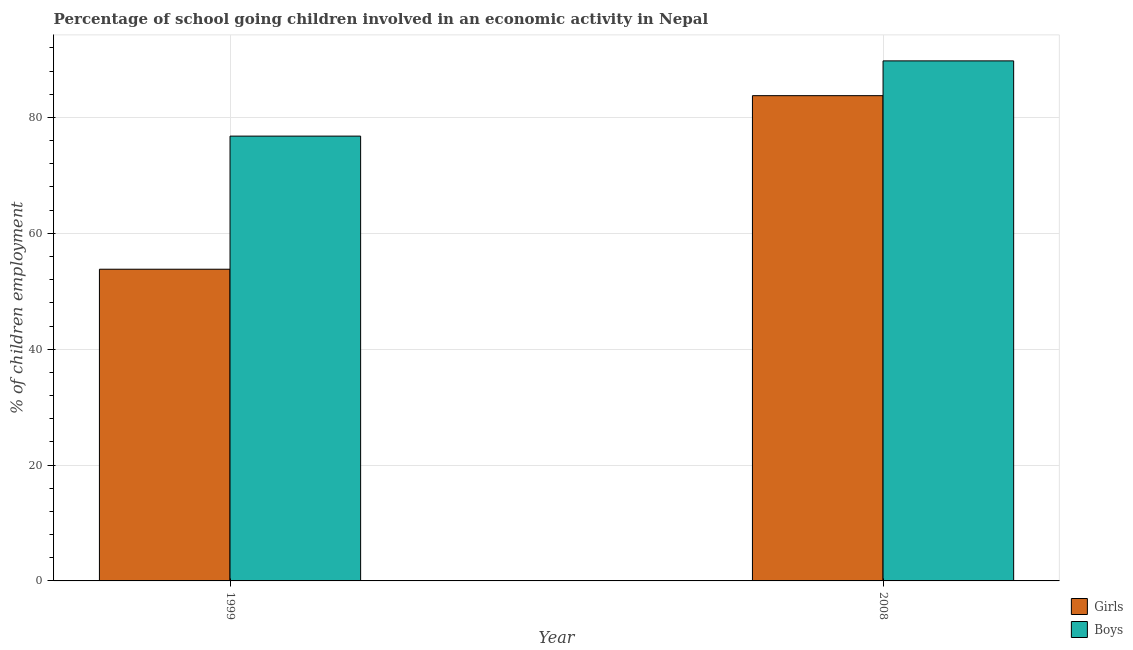How many different coloured bars are there?
Give a very brief answer. 2. Are the number of bars on each tick of the X-axis equal?
Make the answer very short. Yes. What is the label of the 2nd group of bars from the left?
Ensure brevity in your answer.  2008. What is the percentage of school going girls in 1999?
Ensure brevity in your answer.  53.8. Across all years, what is the maximum percentage of school going boys?
Offer a very short reply. 89.76. Across all years, what is the minimum percentage of school going girls?
Your answer should be compact. 53.8. In which year was the percentage of school going girls minimum?
Give a very brief answer. 1999. What is the total percentage of school going boys in the graph?
Provide a succinct answer. 166.54. What is the difference between the percentage of school going girls in 1999 and that in 2008?
Ensure brevity in your answer.  -29.96. What is the difference between the percentage of school going boys in 2008 and the percentage of school going girls in 1999?
Offer a very short reply. 12.99. What is the average percentage of school going girls per year?
Offer a very short reply. 68.78. In how many years, is the percentage of school going boys greater than 68 %?
Ensure brevity in your answer.  2. What is the ratio of the percentage of school going boys in 1999 to that in 2008?
Keep it short and to the point. 0.86. Is the percentage of school going boys in 1999 less than that in 2008?
Offer a very short reply. Yes. What does the 2nd bar from the left in 2008 represents?
Provide a short and direct response. Boys. What does the 1st bar from the right in 2008 represents?
Ensure brevity in your answer.  Boys. Are the values on the major ticks of Y-axis written in scientific E-notation?
Provide a short and direct response. No. Does the graph contain any zero values?
Offer a very short reply. No. How are the legend labels stacked?
Offer a very short reply. Vertical. What is the title of the graph?
Your response must be concise. Percentage of school going children involved in an economic activity in Nepal. What is the label or title of the X-axis?
Offer a terse response. Year. What is the label or title of the Y-axis?
Make the answer very short. % of children employment. What is the % of children employment of Girls in 1999?
Make the answer very short. 53.8. What is the % of children employment of Boys in 1999?
Ensure brevity in your answer.  76.78. What is the % of children employment in Girls in 2008?
Ensure brevity in your answer.  83.76. What is the % of children employment of Boys in 2008?
Keep it short and to the point. 89.76. Across all years, what is the maximum % of children employment in Girls?
Provide a short and direct response. 83.76. Across all years, what is the maximum % of children employment in Boys?
Give a very brief answer. 89.76. Across all years, what is the minimum % of children employment in Girls?
Make the answer very short. 53.8. Across all years, what is the minimum % of children employment in Boys?
Your response must be concise. 76.78. What is the total % of children employment in Girls in the graph?
Provide a succinct answer. 137.56. What is the total % of children employment of Boys in the graph?
Your answer should be compact. 166.54. What is the difference between the % of children employment of Girls in 1999 and that in 2008?
Provide a succinct answer. -29.96. What is the difference between the % of children employment of Boys in 1999 and that in 2008?
Keep it short and to the point. -12.99. What is the difference between the % of children employment of Girls in 1999 and the % of children employment of Boys in 2008?
Your answer should be compact. -35.96. What is the average % of children employment in Girls per year?
Your answer should be very brief. 68.78. What is the average % of children employment in Boys per year?
Your answer should be very brief. 83.27. In the year 1999, what is the difference between the % of children employment in Girls and % of children employment in Boys?
Give a very brief answer. -22.98. In the year 2008, what is the difference between the % of children employment of Girls and % of children employment of Boys?
Offer a terse response. -6. What is the ratio of the % of children employment in Girls in 1999 to that in 2008?
Provide a short and direct response. 0.64. What is the ratio of the % of children employment in Boys in 1999 to that in 2008?
Make the answer very short. 0.86. What is the difference between the highest and the second highest % of children employment in Girls?
Your response must be concise. 29.96. What is the difference between the highest and the second highest % of children employment of Boys?
Your response must be concise. 12.99. What is the difference between the highest and the lowest % of children employment of Girls?
Provide a short and direct response. 29.96. What is the difference between the highest and the lowest % of children employment of Boys?
Make the answer very short. 12.99. 